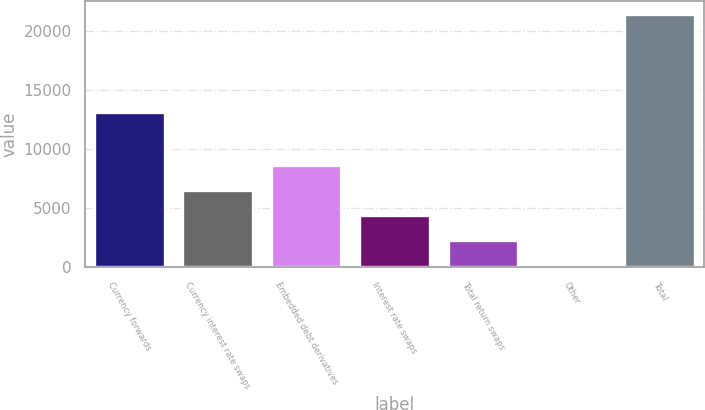<chart> <loc_0><loc_0><loc_500><loc_500><bar_chart><fcel>Currency forwards<fcel>Currency interest rate swaps<fcel>Embedded debt derivatives<fcel>Interest rate swaps<fcel>Total return swaps<fcel>Other<fcel>Total<nl><fcel>13117<fcel>6527.8<fcel>8661.4<fcel>4394.2<fcel>2260.6<fcel>127<fcel>21463<nl></chart> 